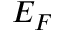<formula> <loc_0><loc_0><loc_500><loc_500>E _ { F }</formula> 